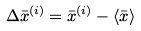<formula> <loc_0><loc_0><loc_500><loc_500>\Delta \bar { x } ^ { ( i ) } = \bar { x } ^ { ( i ) } - \langle \bar { x } \rangle</formula> 